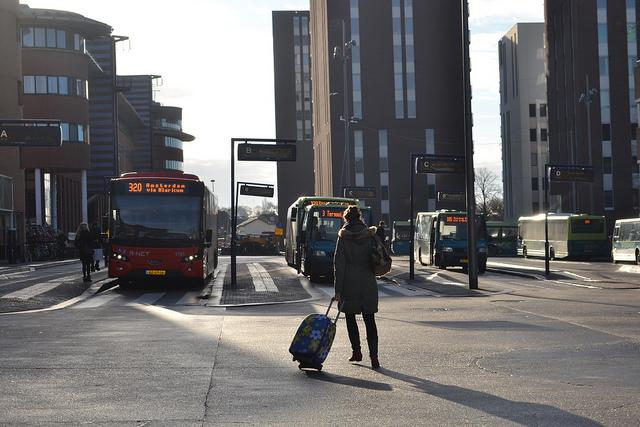What activity is the woman participating in?

Choices:
A) shopping
B) cleaning
C) sleep
D) travel travel 